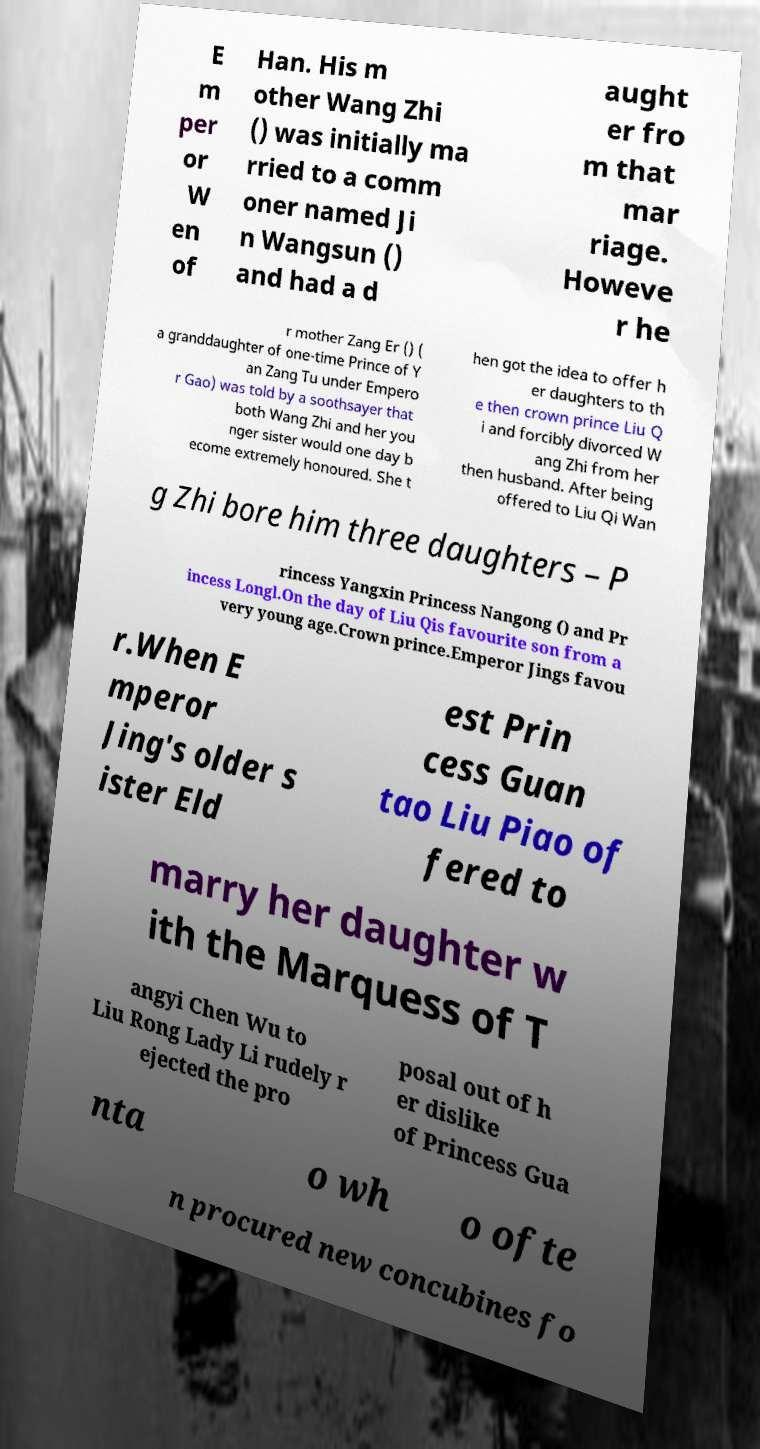Can you read and provide the text displayed in the image?This photo seems to have some interesting text. Can you extract and type it out for me? E m per or W en of Han. His m other Wang Zhi () was initially ma rried to a comm oner named Ji n Wangsun () and had a d aught er fro m that mar riage. Howeve r he r mother Zang Er () ( a granddaughter of one-time Prince of Y an Zang Tu under Empero r Gao) was told by a soothsayer that both Wang Zhi and her you nger sister would one day b ecome extremely honoured. She t hen got the idea to offer h er daughters to th e then crown prince Liu Q i and forcibly divorced W ang Zhi from her then husband. After being offered to Liu Qi Wan g Zhi bore him three daughters – P rincess Yangxin Princess Nangong () and Pr incess Longl.On the day of Liu Qis favourite son from a very young age.Crown prince.Emperor Jings favou r.When E mperor Jing's older s ister Eld est Prin cess Guan tao Liu Piao of fered to marry her daughter w ith the Marquess of T angyi Chen Wu to Liu Rong Lady Li rudely r ejected the pro posal out of h er dislike of Princess Gua nta o wh o ofte n procured new concubines fo 